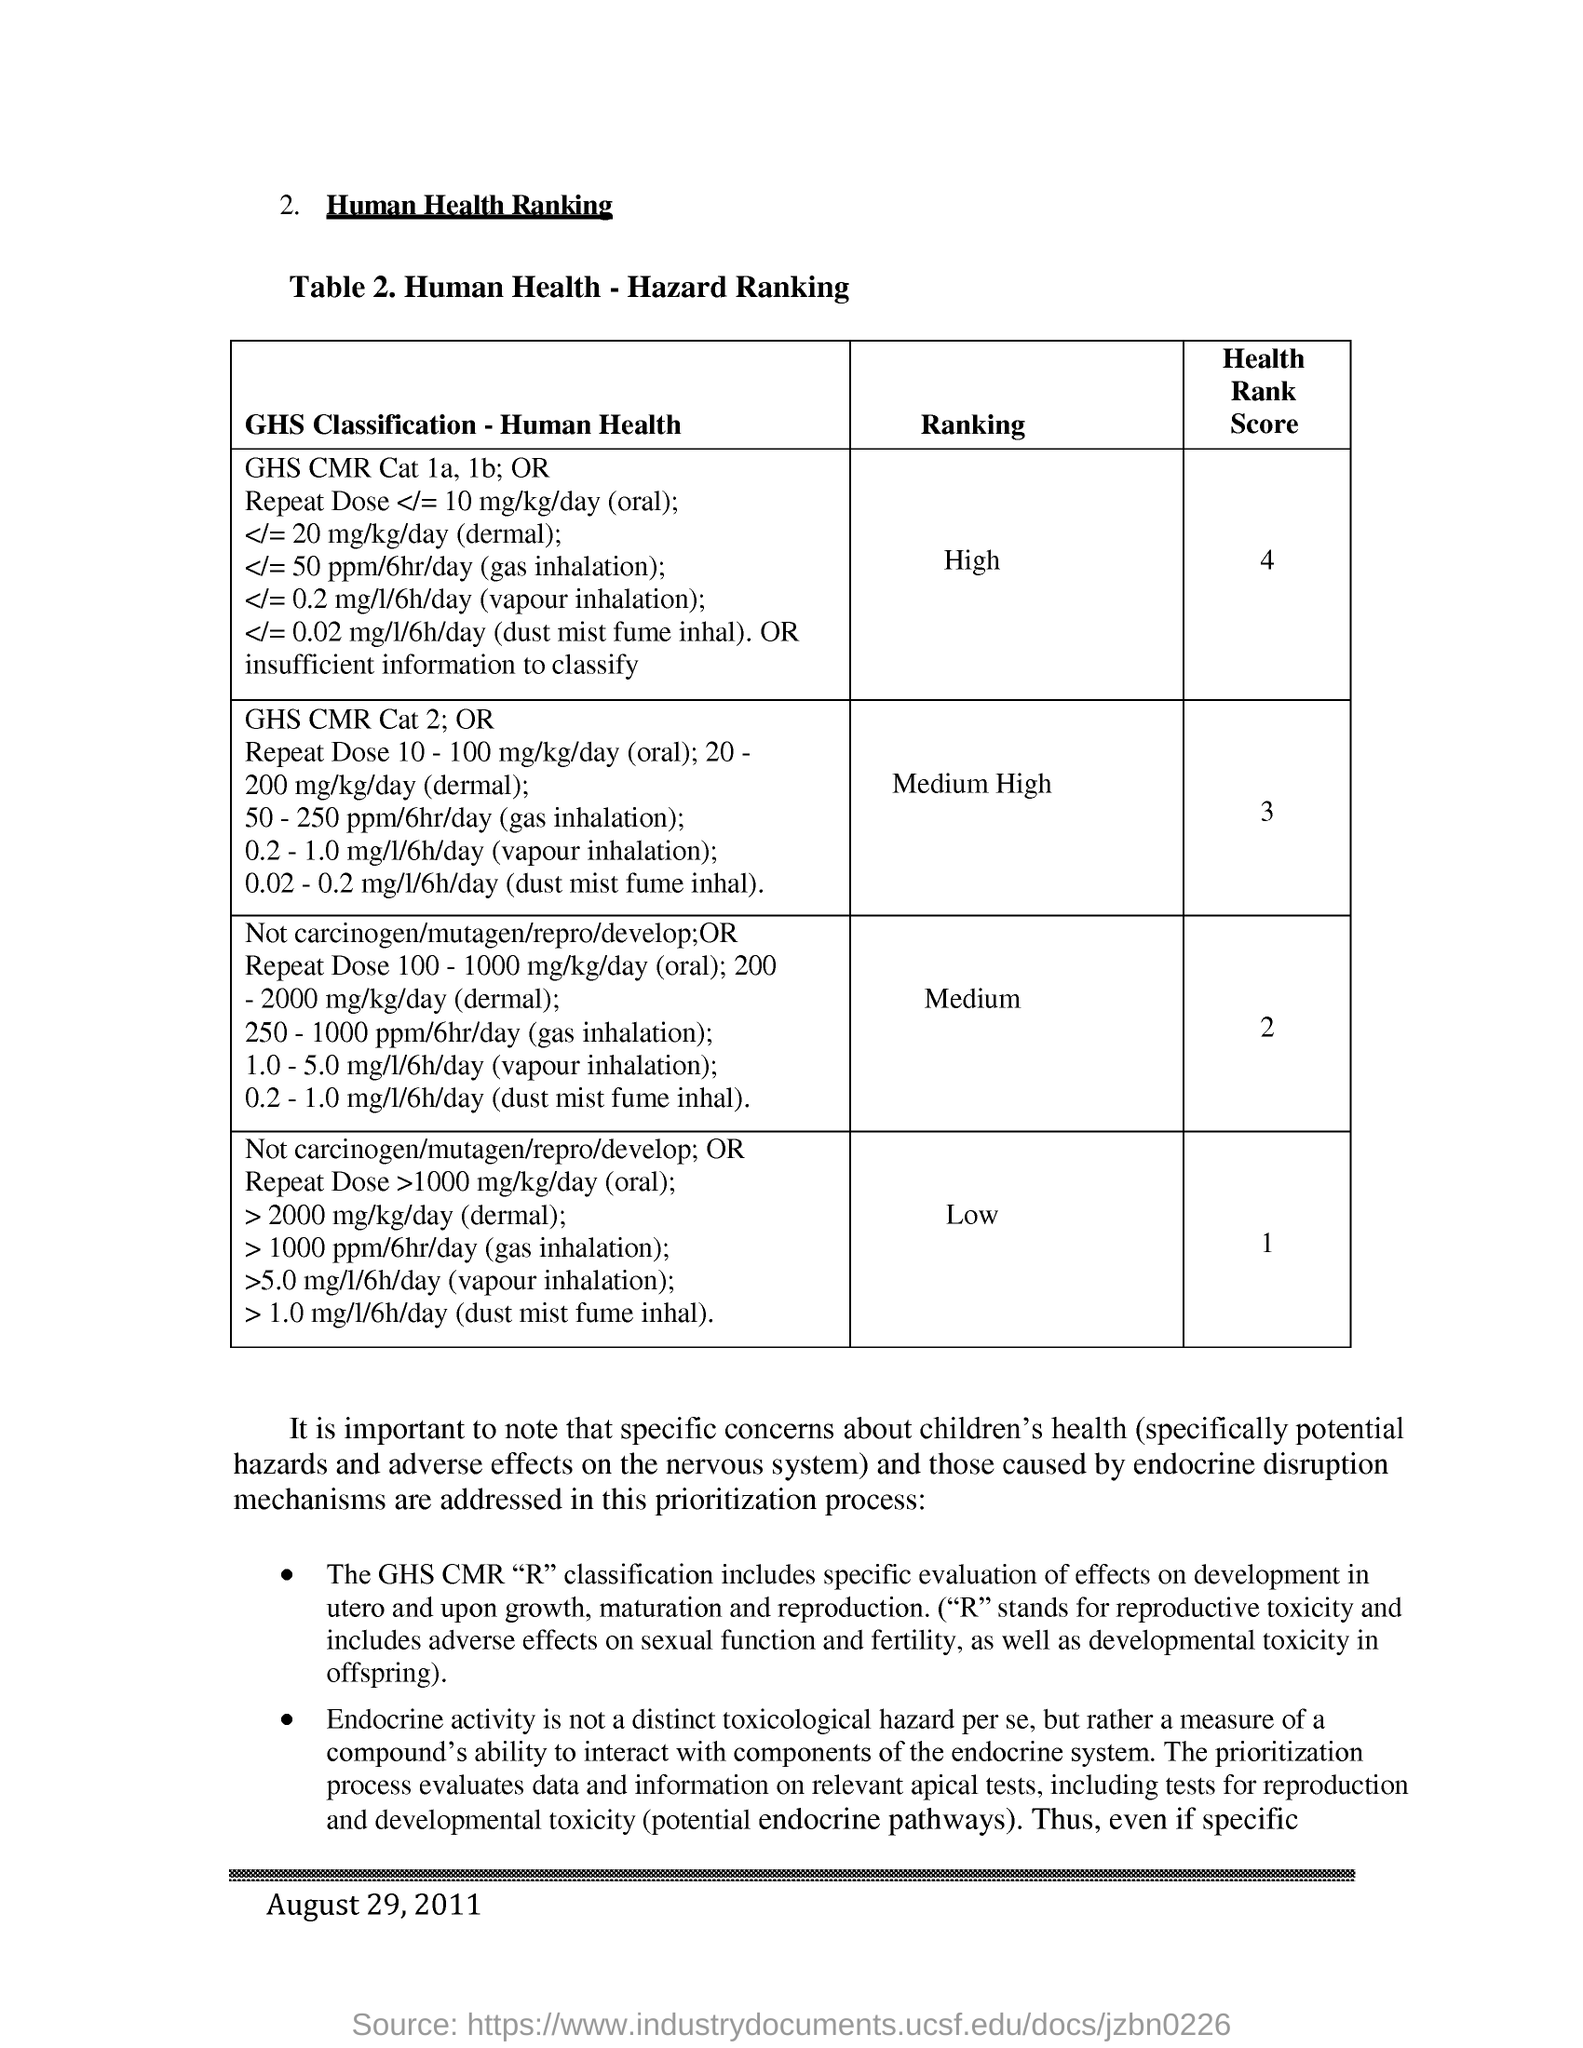What is the heading of the document?
Your answer should be compact. HUMAN HEALTH RANKING. What is the Ranking of Health Rank Score: 1?
Ensure brevity in your answer.  Low. Health Rank Score of Ranking: Medium High?
Offer a terse response. 3. What is the date mentioned in this document?
Your response must be concise. August 29, 2011. 